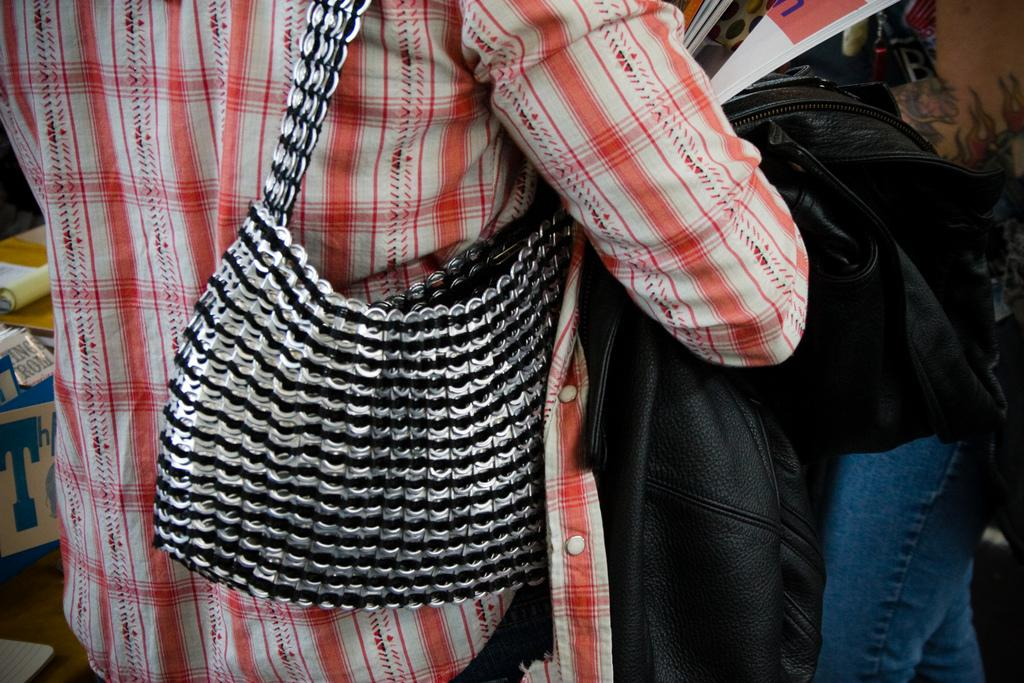Who or what is the main subject in the image? There is a person in the image. What is the person wearing? The person is wearing a handbag. What else is the person holding in the image? The person is holding a jacket in her hands. What can be seen in the background of the image? There are boxes in the background of the image. What type of ship can be seen in the image? There is no ship present in the image; it features a person wearing a handbag and holding a jacket, with boxes in the background. 